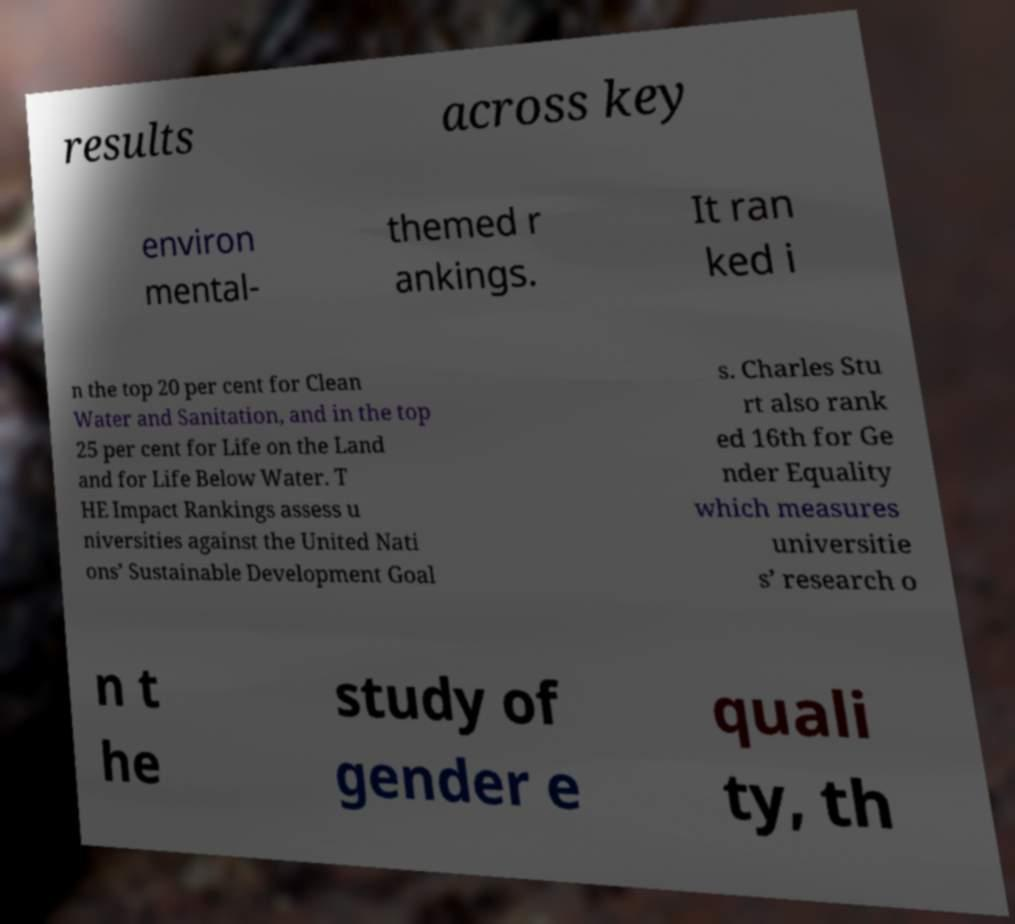Can you read and provide the text displayed in the image?This photo seems to have some interesting text. Can you extract and type it out for me? results across key environ mental- themed r ankings. It ran ked i n the top 20 per cent for Clean Water and Sanitation, and in the top 25 per cent for Life on the Land and for Life Below Water. T HE Impact Rankings assess u niversities against the United Nati ons’ Sustainable Development Goal s. Charles Stu rt also rank ed 16th for Ge nder Equality which measures universitie s’ research o n t he study of gender e quali ty, th 